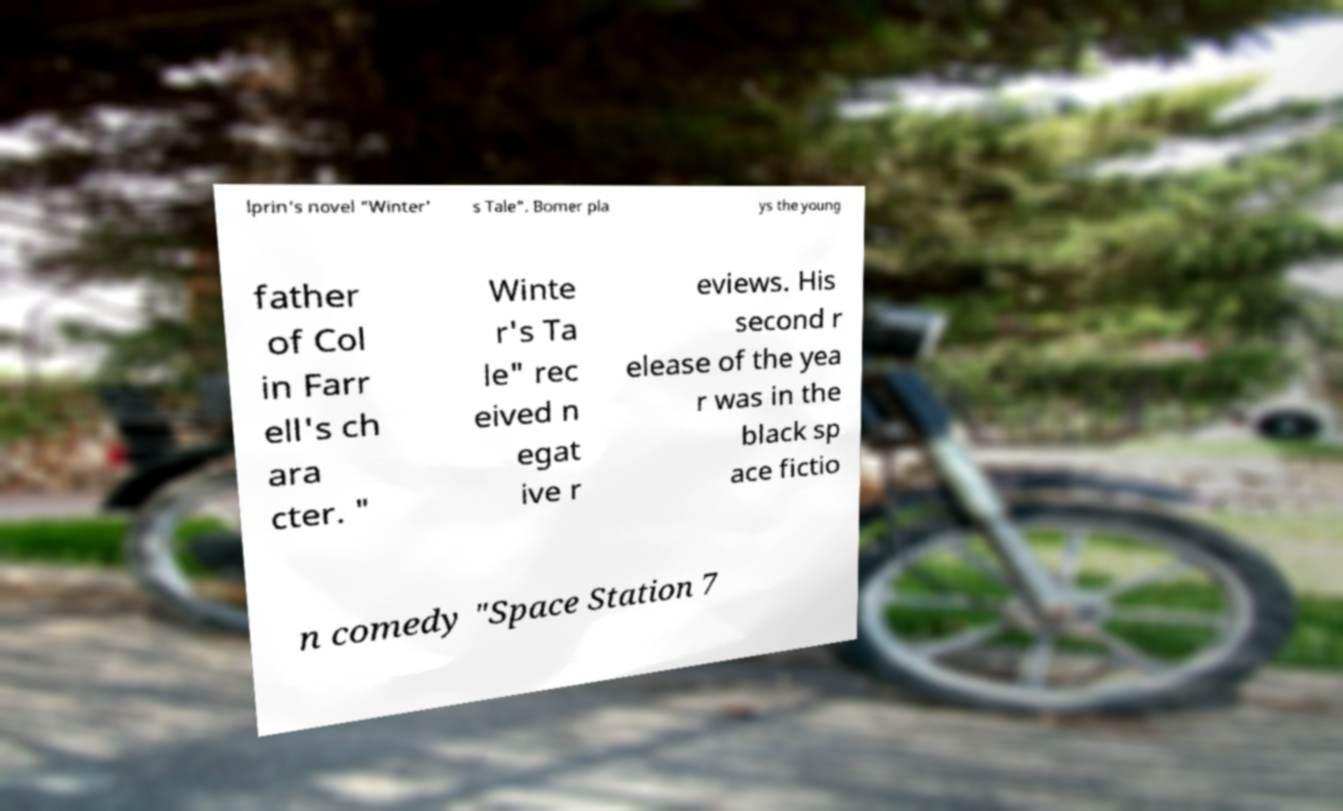There's text embedded in this image that I need extracted. Can you transcribe it verbatim? lprin's novel "Winter' s Tale". Bomer pla ys the young father of Col in Farr ell's ch ara cter. " Winte r's Ta le" rec eived n egat ive r eviews. His second r elease of the yea r was in the black sp ace fictio n comedy "Space Station 7 